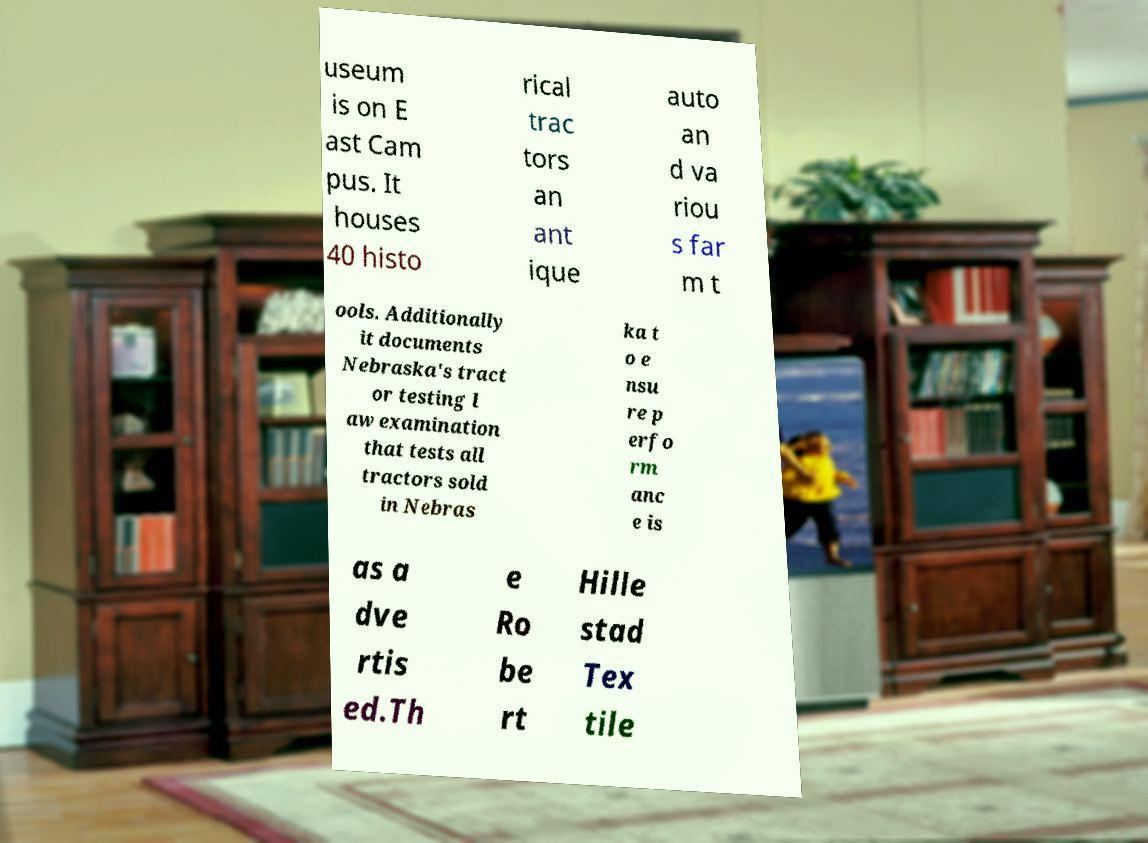Could you assist in decoding the text presented in this image and type it out clearly? useum is on E ast Cam pus. It houses 40 histo rical trac tors an ant ique auto an d va riou s far m t ools. Additionally it documents Nebraska's tract or testing l aw examination that tests all tractors sold in Nebras ka t o e nsu re p erfo rm anc e is as a dve rtis ed.Th e Ro be rt Hille stad Tex tile 